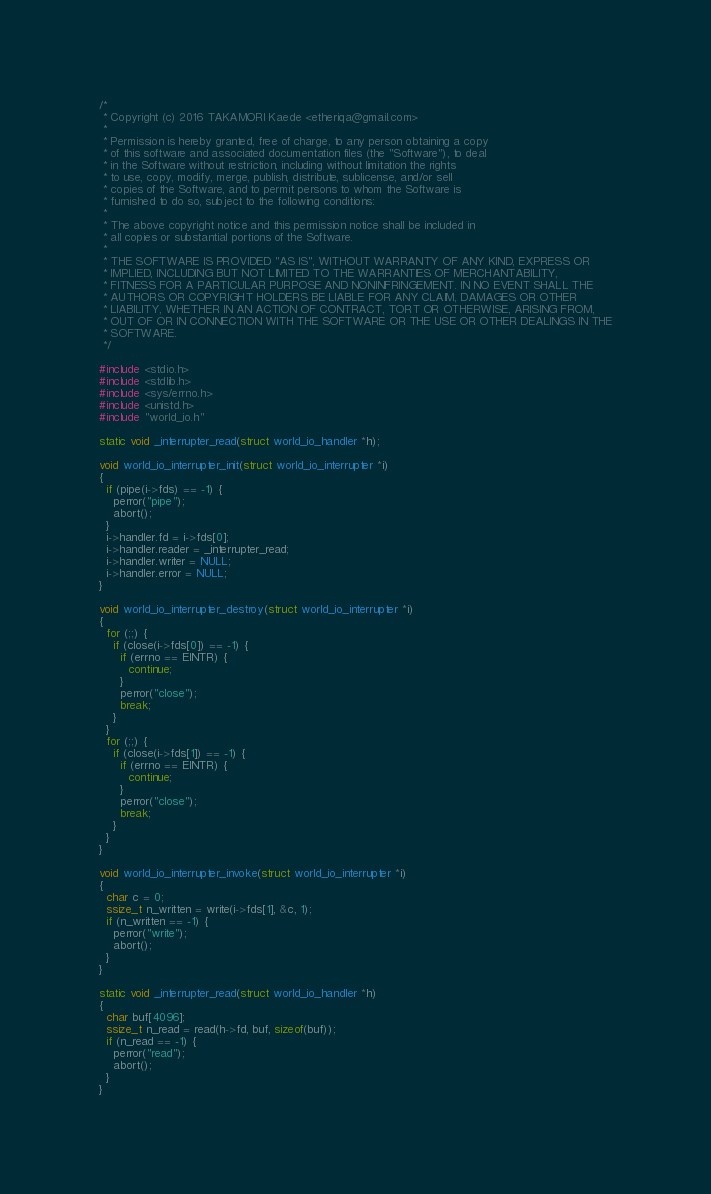<code> <loc_0><loc_0><loc_500><loc_500><_C_>/*
 * Copyright (c) 2016 TAKAMORI Kaede <etheriqa@gmail.com>
 *
 * Permission is hereby granted, free of charge, to any person obtaining a copy
 * of this software and associated documentation files (the "Software"), to deal
 * in the Software without restriction, including without limitation the rights
 * to use, copy, modify, merge, publish, distribute, sublicense, and/or sell
 * copies of the Software, and to permit persons to whom the Software is
 * furnished to do so, subject to the following conditions:
 *
 * The above copyright notice and this permission notice shall be included in
 * all copies or substantial portions of the Software.
 *
 * THE SOFTWARE IS PROVIDED "AS IS", WITHOUT WARRANTY OF ANY KIND, EXPRESS OR
 * IMPLIED, INCLUDING BUT NOT LIMITED TO THE WARRANTIES OF MERCHANTABILITY,
 * FITNESS FOR A PARTICULAR PURPOSE AND NONINFRINGEMENT. IN NO EVENT SHALL THE
 * AUTHORS OR COPYRIGHT HOLDERS BE LIABLE FOR ANY CLAIM, DAMAGES OR OTHER
 * LIABILITY, WHETHER IN AN ACTION OF CONTRACT, TORT OR OTHERWISE, ARISING FROM,
 * OUT OF OR IN CONNECTION WITH THE SOFTWARE OR THE USE OR OTHER DEALINGS IN THE
 * SOFTWARE.
 */

#include <stdio.h>
#include <stdlib.h>
#include <sys/errno.h>
#include <unistd.h>
#include "world_io.h"

static void _interrupter_read(struct world_io_handler *h);

void world_io_interrupter_init(struct world_io_interrupter *i)
{
  if (pipe(i->fds) == -1) {
    perror("pipe");
    abort();
  }
  i->handler.fd = i->fds[0];
  i->handler.reader = _interrupter_read;
  i->handler.writer = NULL;
  i->handler.error = NULL;
}

void world_io_interrupter_destroy(struct world_io_interrupter *i)
{
  for (;;) {
    if (close(i->fds[0]) == -1) {
      if (errno == EINTR) {
        continue;
      }
      perror("close");
      break;
    }
  }
  for (;;) {
    if (close(i->fds[1]) == -1) {
      if (errno == EINTR) {
        continue;
      }
      perror("close");
      break;
    }
  }
}

void world_io_interrupter_invoke(struct world_io_interrupter *i)
{
  char c = 0;
  ssize_t n_written = write(i->fds[1], &c, 1);
  if (n_written == -1) {
    perror("write");
    abort();
  }
}

static void _interrupter_read(struct world_io_handler *h)
{
  char buf[4096];
  ssize_t n_read = read(h->fd, buf, sizeof(buf));
  if (n_read == -1) {
    perror("read");
    abort();
  }
}
</code> 